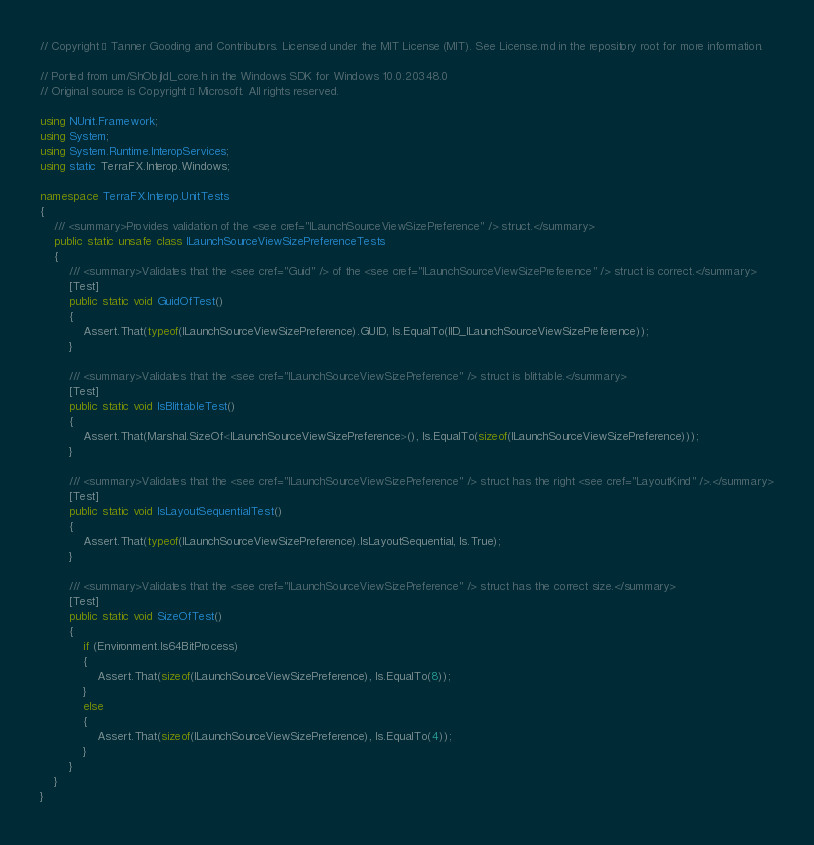<code> <loc_0><loc_0><loc_500><loc_500><_C#_>// Copyright © Tanner Gooding and Contributors. Licensed under the MIT License (MIT). See License.md in the repository root for more information.

// Ported from um/ShObjIdl_core.h in the Windows SDK for Windows 10.0.20348.0
// Original source is Copyright © Microsoft. All rights reserved.

using NUnit.Framework;
using System;
using System.Runtime.InteropServices;
using static TerraFX.Interop.Windows;

namespace TerraFX.Interop.UnitTests
{
    /// <summary>Provides validation of the <see cref="ILaunchSourceViewSizePreference" /> struct.</summary>
    public static unsafe class ILaunchSourceViewSizePreferenceTests
    {
        /// <summary>Validates that the <see cref="Guid" /> of the <see cref="ILaunchSourceViewSizePreference" /> struct is correct.</summary>
        [Test]
        public static void GuidOfTest()
        {
            Assert.That(typeof(ILaunchSourceViewSizePreference).GUID, Is.EqualTo(IID_ILaunchSourceViewSizePreference));
        }

        /// <summary>Validates that the <see cref="ILaunchSourceViewSizePreference" /> struct is blittable.</summary>
        [Test]
        public static void IsBlittableTest()
        {
            Assert.That(Marshal.SizeOf<ILaunchSourceViewSizePreference>(), Is.EqualTo(sizeof(ILaunchSourceViewSizePreference)));
        }

        /// <summary>Validates that the <see cref="ILaunchSourceViewSizePreference" /> struct has the right <see cref="LayoutKind" />.</summary>
        [Test]
        public static void IsLayoutSequentialTest()
        {
            Assert.That(typeof(ILaunchSourceViewSizePreference).IsLayoutSequential, Is.True);
        }

        /// <summary>Validates that the <see cref="ILaunchSourceViewSizePreference" /> struct has the correct size.</summary>
        [Test]
        public static void SizeOfTest()
        {
            if (Environment.Is64BitProcess)
            {
                Assert.That(sizeof(ILaunchSourceViewSizePreference), Is.EqualTo(8));
            }
            else
            {
                Assert.That(sizeof(ILaunchSourceViewSizePreference), Is.EqualTo(4));
            }
        }
    }
}
</code> 